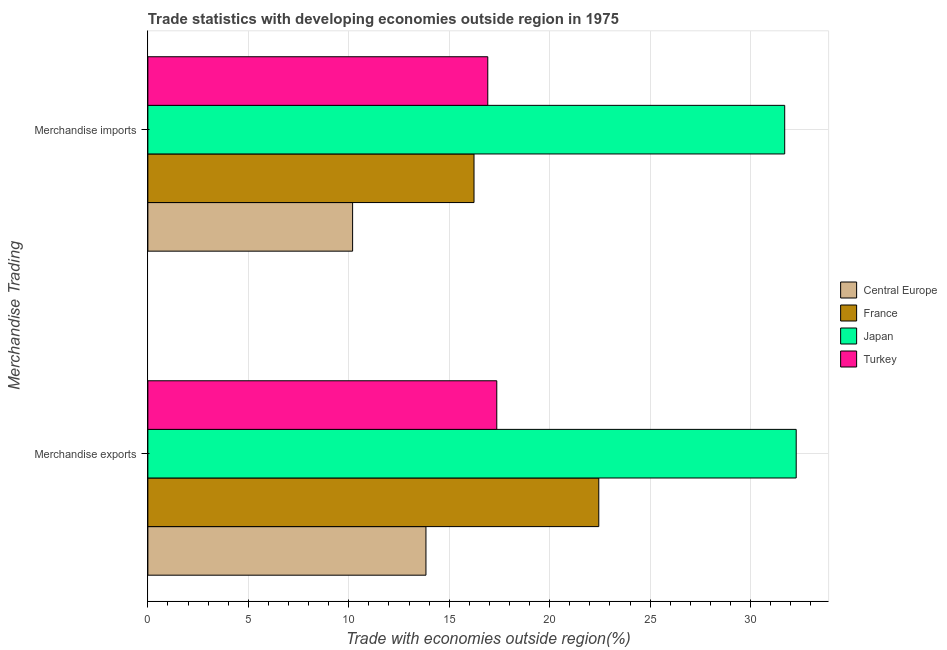Are the number of bars on each tick of the Y-axis equal?
Provide a short and direct response. Yes. What is the merchandise imports in France?
Keep it short and to the point. 16.23. Across all countries, what is the maximum merchandise imports?
Give a very brief answer. 31.7. Across all countries, what is the minimum merchandise exports?
Ensure brevity in your answer.  13.84. In which country was the merchandise imports maximum?
Ensure brevity in your answer.  Japan. In which country was the merchandise exports minimum?
Give a very brief answer. Central Europe. What is the total merchandise exports in the graph?
Provide a short and direct response. 85.92. What is the difference between the merchandise exports in Central Europe and that in Japan?
Make the answer very short. -18.43. What is the difference between the merchandise exports in Japan and the merchandise imports in Turkey?
Give a very brief answer. 15.35. What is the average merchandise exports per country?
Your answer should be compact. 21.48. What is the difference between the merchandise imports and merchandise exports in France?
Give a very brief answer. -6.21. What is the ratio of the merchandise imports in Japan to that in Central Europe?
Offer a terse response. 3.11. In how many countries, is the merchandise imports greater than the average merchandise imports taken over all countries?
Make the answer very short. 1. What does the 1st bar from the bottom in Merchandise exports represents?
Provide a short and direct response. Central Europe. How many bars are there?
Your answer should be compact. 8. Are all the bars in the graph horizontal?
Provide a succinct answer. Yes. Are the values on the major ticks of X-axis written in scientific E-notation?
Your answer should be compact. No. Does the graph contain any zero values?
Provide a short and direct response. No. Does the graph contain grids?
Provide a succinct answer. Yes. Where does the legend appear in the graph?
Your answer should be compact. Center right. How many legend labels are there?
Your answer should be very brief. 4. What is the title of the graph?
Provide a short and direct response. Trade statistics with developing economies outside region in 1975. Does "Afghanistan" appear as one of the legend labels in the graph?
Make the answer very short. No. What is the label or title of the X-axis?
Provide a short and direct response. Trade with economies outside region(%). What is the label or title of the Y-axis?
Offer a terse response. Merchandise Trading. What is the Trade with economies outside region(%) of Central Europe in Merchandise exports?
Provide a succinct answer. 13.84. What is the Trade with economies outside region(%) in France in Merchandise exports?
Your answer should be very brief. 22.44. What is the Trade with economies outside region(%) in Japan in Merchandise exports?
Make the answer very short. 32.27. What is the Trade with economies outside region(%) of Turkey in Merchandise exports?
Your answer should be very brief. 17.37. What is the Trade with economies outside region(%) of Central Europe in Merchandise imports?
Your answer should be compact. 10.19. What is the Trade with economies outside region(%) of France in Merchandise imports?
Your answer should be very brief. 16.23. What is the Trade with economies outside region(%) of Japan in Merchandise imports?
Your answer should be very brief. 31.7. What is the Trade with economies outside region(%) of Turkey in Merchandise imports?
Make the answer very short. 16.92. Across all Merchandise Trading, what is the maximum Trade with economies outside region(%) of Central Europe?
Offer a very short reply. 13.84. Across all Merchandise Trading, what is the maximum Trade with economies outside region(%) in France?
Keep it short and to the point. 22.44. Across all Merchandise Trading, what is the maximum Trade with economies outside region(%) of Japan?
Keep it short and to the point. 32.27. Across all Merchandise Trading, what is the maximum Trade with economies outside region(%) of Turkey?
Offer a very short reply. 17.37. Across all Merchandise Trading, what is the minimum Trade with economies outside region(%) in Central Europe?
Give a very brief answer. 10.19. Across all Merchandise Trading, what is the minimum Trade with economies outside region(%) in France?
Offer a very short reply. 16.23. Across all Merchandise Trading, what is the minimum Trade with economies outside region(%) in Japan?
Ensure brevity in your answer.  31.7. Across all Merchandise Trading, what is the minimum Trade with economies outside region(%) of Turkey?
Your answer should be compact. 16.92. What is the total Trade with economies outside region(%) in Central Europe in the graph?
Offer a terse response. 24.03. What is the total Trade with economies outside region(%) in France in the graph?
Provide a succinct answer. 38.68. What is the total Trade with economies outside region(%) in Japan in the graph?
Provide a succinct answer. 63.96. What is the total Trade with economies outside region(%) of Turkey in the graph?
Provide a short and direct response. 34.28. What is the difference between the Trade with economies outside region(%) of Central Europe in Merchandise exports and that in Merchandise imports?
Offer a very short reply. 3.65. What is the difference between the Trade with economies outside region(%) in France in Merchandise exports and that in Merchandise imports?
Make the answer very short. 6.21. What is the difference between the Trade with economies outside region(%) in Japan in Merchandise exports and that in Merchandise imports?
Provide a succinct answer. 0.57. What is the difference between the Trade with economies outside region(%) of Turkey in Merchandise exports and that in Merchandise imports?
Offer a terse response. 0.45. What is the difference between the Trade with economies outside region(%) of Central Europe in Merchandise exports and the Trade with economies outside region(%) of France in Merchandise imports?
Offer a terse response. -2.39. What is the difference between the Trade with economies outside region(%) in Central Europe in Merchandise exports and the Trade with economies outside region(%) in Japan in Merchandise imports?
Provide a succinct answer. -17.86. What is the difference between the Trade with economies outside region(%) in Central Europe in Merchandise exports and the Trade with economies outside region(%) in Turkey in Merchandise imports?
Make the answer very short. -3.08. What is the difference between the Trade with economies outside region(%) in France in Merchandise exports and the Trade with economies outside region(%) in Japan in Merchandise imports?
Make the answer very short. -9.25. What is the difference between the Trade with economies outside region(%) in France in Merchandise exports and the Trade with economies outside region(%) in Turkey in Merchandise imports?
Make the answer very short. 5.52. What is the difference between the Trade with economies outside region(%) of Japan in Merchandise exports and the Trade with economies outside region(%) of Turkey in Merchandise imports?
Ensure brevity in your answer.  15.35. What is the average Trade with economies outside region(%) of Central Europe per Merchandise Trading?
Provide a short and direct response. 12.02. What is the average Trade with economies outside region(%) in France per Merchandise Trading?
Provide a short and direct response. 19.34. What is the average Trade with economies outside region(%) of Japan per Merchandise Trading?
Offer a very short reply. 31.98. What is the average Trade with economies outside region(%) of Turkey per Merchandise Trading?
Offer a terse response. 17.14. What is the difference between the Trade with economies outside region(%) of Central Europe and Trade with economies outside region(%) of France in Merchandise exports?
Make the answer very short. -8.6. What is the difference between the Trade with economies outside region(%) of Central Europe and Trade with economies outside region(%) of Japan in Merchandise exports?
Keep it short and to the point. -18.43. What is the difference between the Trade with economies outside region(%) in Central Europe and Trade with economies outside region(%) in Turkey in Merchandise exports?
Offer a very short reply. -3.52. What is the difference between the Trade with economies outside region(%) in France and Trade with economies outside region(%) in Japan in Merchandise exports?
Provide a succinct answer. -9.83. What is the difference between the Trade with economies outside region(%) of France and Trade with economies outside region(%) of Turkey in Merchandise exports?
Make the answer very short. 5.08. What is the difference between the Trade with economies outside region(%) of Japan and Trade with economies outside region(%) of Turkey in Merchandise exports?
Provide a short and direct response. 14.9. What is the difference between the Trade with economies outside region(%) of Central Europe and Trade with economies outside region(%) of France in Merchandise imports?
Offer a very short reply. -6.04. What is the difference between the Trade with economies outside region(%) of Central Europe and Trade with economies outside region(%) of Japan in Merchandise imports?
Make the answer very short. -21.51. What is the difference between the Trade with economies outside region(%) of Central Europe and Trade with economies outside region(%) of Turkey in Merchandise imports?
Your response must be concise. -6.73. What is the difference between the Trade with economies outside region(%) in France and Trade with economies outside region(%) in Japan in Merchandise imports?
Provide a short and direct response. -15.46. What is the difference between the Trade with economies outside region(%) of France and Trade with economies outside region(%) of Turkey in Merchandise imports?
Ensure brevity in your answer.  -0.69. What is the difference between the Trade with economies outside region(%) of Japan and Trade with economies outside region(%) of Turkey in Merchandise imports?
Your response must be concise. 14.78. What is the ratio of the Trade with economies outside region(%) in Central Europe in Merchandise exports to that in Merchandise imports?
Keep it short and to the point. 1.36. What is the ratio of the Trade with economies outside region(%) in France in Merchandise exports to that in Merchandise imports?
Your answer should be very brief. 1.38. What is the ratio of the Trade with economies outside region(%) in Japan in Merchandise exports to that in Merchandise imports?
Give a very brief answer. 1.02. What is the ratio of the Trade with economies outside region(%) in Turkey in Merchandise exports to that in Merchandise imports?
Offer a very short reply. 1.03. What is the difference between the highest and the second highest Trade with economies outside region(%) in Central Europe?
Your answer should be compact. 3.65. What is the difference between the highest and the second highest Trade with economies outside region(%) in France?
Your answer should be very brief. 6.21. What is the difference between the highest and the second highest Trade with economies outside region(%) in Japan?
Provide a short and direct response. 0.57. What is the difference between the highest and the second highest Trade with economies outside region(%) in Turkey?
Provide a succinct answer. 0.45. What is the difference between the highest and the lowest Trade with economies outside region(%) of Central Europe?
Your answer should be compact. 3.65. What is the difference between the highest and the lowest Trade with economies outside region(%) of France?
Offer a terse response. 6.21. What is the difference between the highest and the lowest Trade with economies outside region(%) in Japan?
Your answer should be compact. 0.57. What is the difference between the highest and the lowest Trade with economies outside region(%) of Turkey?
Provide a short and direct response. 0.45. 